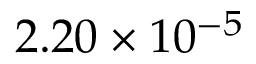Convert formula to latex. <formula><loc_0><loc_0><loc_500><loc_500>2 . 2 0 \times 1 0 ^ { - 5 }</formula> 